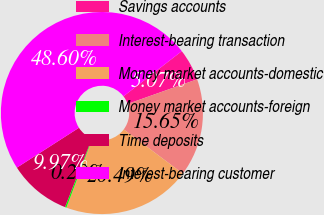Convert chart to OTSL. <chart><loc_0><loc_0><loc_500><loc_500><pie_chart><fcel>Savings accounts<fcel>Interest-bearing transaction<fcel>Money market accounts-domestic<fcel>Money market accounts-foreign<fcel>Time deposits<fcel>Interest-bearing customer<nl><fcel>5.07%<fcel>15.65%<fcel>20.49%<fcel>0.23%<fcel>9.97%<fcel>48.6%<nl></chart> 